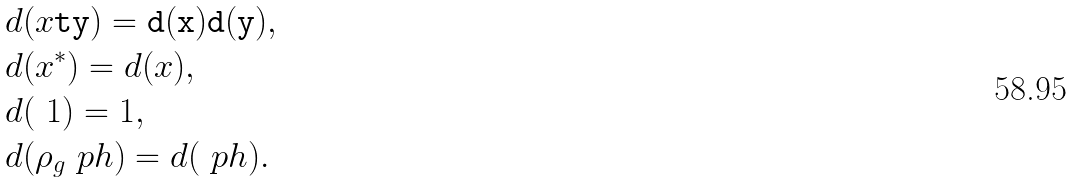<formula> <loc_0><loc_0><loc_500><loc_500>& d ( x \tt t y ) = d ( x ) d ( y ) , \\ & d ( x ^ { * } ) = d ( x ) , \\ & d ( \ 1 ) = 1 , \\ & d ( \rho _ { g } \ p h ) = d ( \ p h ) .</formula> 